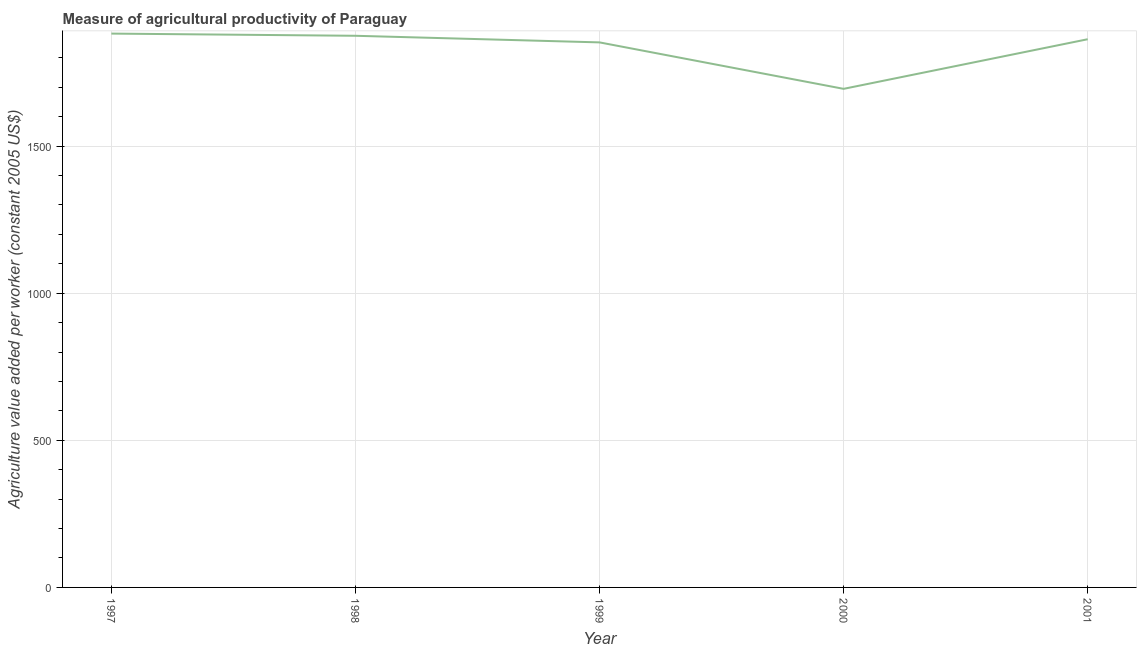What is the agriculture value added per worker in 1998?
Provide a succinct answer. 1874.62. Across all years, what is the maximum agriculture value added per worker?
Offer a terse response. 1882.06. Across all years, what is the minimum agriculture value added per worker?
Your response must be concise. 1694.29. What is the sum of the agriculture value added per worker?
Your response must be concise. 9166.02. What is the difference between the agriculture value added per worker in 1997 and 2000?
Make the answer very short. 187.77. What is the average agriculture value added per worker per year?
Offer a very short reply. 1833.2. What is the median agriculture value added per worker?
Your response must be concise. 1862.88. Do a majority of the years between 2001 and 2000 (inclusive) have agriculture value added per worker greater than 1600 US$?
Your response must be concise. No. What is the ratio of the agriculture value added per worker in 1998 to that in 1999?
Provide a succinct answer. 1.01. What is the difference between the highest and the second highest agriculture value added per worker?
Provide a short and direct response. 7.43. Is the sum of the agriculture value added per worker in 1997 and 2000 greater than the maximum agriculture value added per worker across all years?
Your answer should be compact. Yes. What is the difference between the highest and the lowest agriculture value added per worker?
Your response must be concise. 187.77. In how many years, is the agriculture value added per worker greater than the average agriculture value added per worker taken over all years?
Provide a succinct answer. 4. Does the agriculture value added per worker monotonically increase over the years?
Your answer should be very brief. No. How many lines are there?
Your answer should be compact. 1. What is the difference between two consecutive major ticks on the Y-axis?
Make the answer very short. 500. Are the values on the major ticks of Y-axis written in scientific E-notation?
Ensure brevity in your answer.  No. What is the title of the graph?
Give a very brief answer. Measure of agricultural productivity of Paraguay. What is the label or title of the X-axis?
Make the answer very short. Year. What is the label or title of the Y-axis?
Offer a terse response. Agriculture value added per worker (constant 2005 US$). What is the Agriculture value added per worker (constant 2005 US$) in 1997?
Provide a short and direct response. 1882.06. What is the Agriculture value added per worker (constant 2005 US$) in 1998?
Provide a succinct answer. 1874.62. What is the Agriculture value added per worker (constant 2005 US$) in 1999?
Provide a succinct answer. 1852.16. What is the Agriculture value added per worker (constant 2005 US$) of 2000?
Provide a succinct answer. 1694.29. What is the Agriculture value added per worker (constant 2005 US$) of 2001?
Offer a very short reply. 1862.88. What is the difference between the Agriculture value added per worker (constant 2005 US$) in 1997 and 1998?
Offer a terse response. 7.43. What is the difference between the Agriculture value added per worker (constant 2005 US$) in 1997 and 1999?
Your response must be concise. 29.9. What is the difference between the Agriculture value added per worker (constant 2005 US$) in 1997 and 2000?
Your answer should be compact. 187.77. What is the difference between the Agriculture value added per worker (constant 2005 US$) in 1997 and 2001?
Your answer should be compact. 19.18. What is the difference between the Agriculture value added per worker (constant 2005 US$) in 1998 and 1999?
Your answer should be compact. 22.46. What is the difference between the Agriculture value added per worker (constant 2005 US$) in 1998 and 2000?
Your response must be concise. 180.33. What is the difference between the Agriculture value added per worker (constant 2005 US$) in 1998 and 2001?
Offer a terse response. 11.74. What is the difference between the Agriculture value added per worker (constant 2005 US$) in 1999 and 2000?
Keep it short and to the point. 157.87. What is the difference between the Agriculture value added per worker (constant 2005 US$) in 1999 and 2001?
Give a very brief answer. -10.72. What is the difference between the Agriculture value added per worker (constant 2005 US$) in 2000 and 2001?
Provide a succinct answer. -168.59. What is the ratio of the Agriculture value added per worker (constant 2005 US$) in 1997 to that in 1998?
Offer a very short reply. 1. What is the ratio of the Agriculture value added per worker (constant 2005 US$) in 1997 to that in 2000?
Your response must be concise. 1.11. What is the ratio of the Agriculture value added per worker (constant 2005 US$) in 1997 to that in 2001?
Keep it short and to the point. 1.01. What is the ratio of the Agriculture value added per worker (constant 2005 US$) in 1998 to that in 2000?
Provide a succinct answer. 1.11. What is the ratio of the Agriculture value added per worker (constant 2005 US$) in 1998 to that in 2001?
Your answer should be compact. 1.01. What is the ratio of the Agriculture value added per worker (constant 2005 US$) in 1999 to that in 2000?
Your answer should be compact. 1.09. What is the ratio of the Agriculture value added per worker (constant 2005 US$) in 1999 to that in 2001?
Provide a succinct answer. 0.99. What is the ratio of the Agriculture value added per worker (constant 2005 US$) in 2000 to that in 2001?
Ensure brevity in your answer.  0.91. 